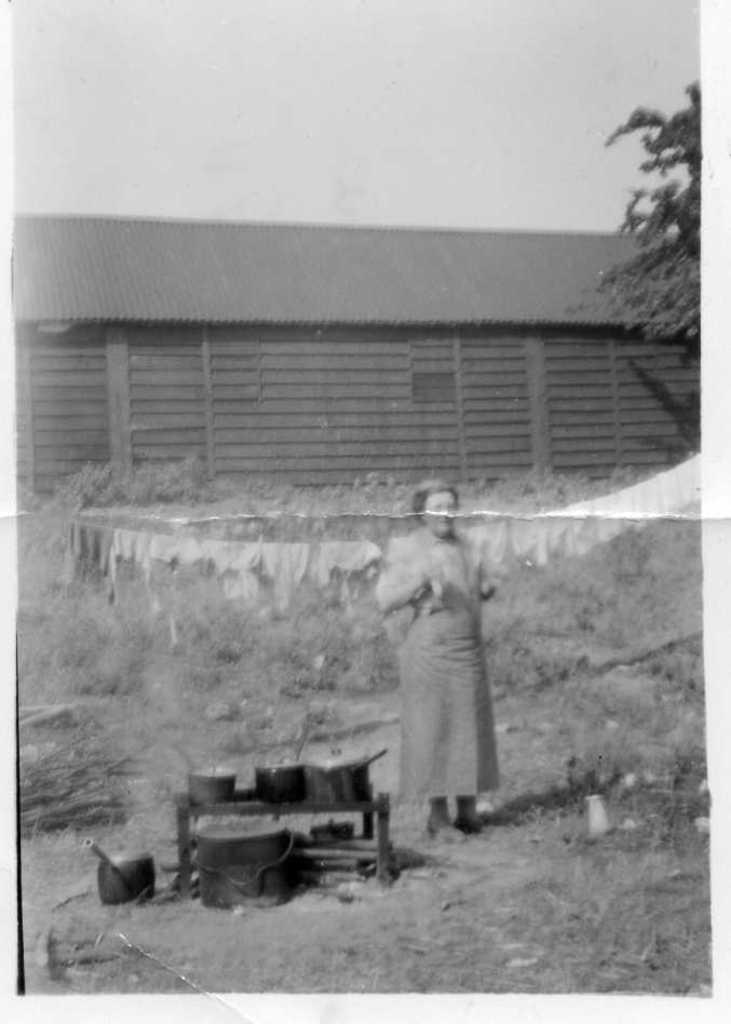Who is present in the image? There is a lady in the image. What is the lady doing in the image? The facts provided do not specify what the lady is doing. What can be seen on the stove in the image? There are utensils placed on the stove. What is visible in the background of the image? There is a shed and a tree in the background of the image. What type of business is being conducted in the shed in the image? There is no indication of a business or any activity taking place in the shed in the image. 